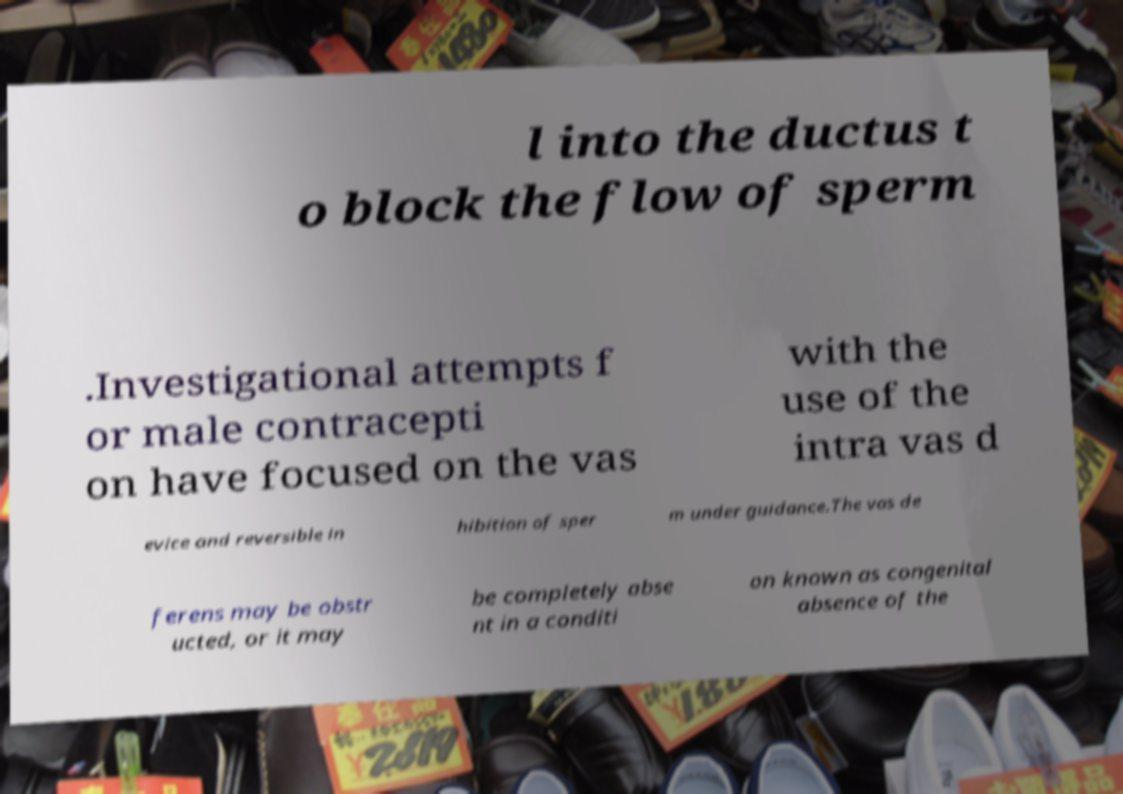Could you assist in decoding the text presented in this image and type it out clearly? l into the ductus t o block the flow of sperm .Investigational attempts f or male contracepti on have focused on the vas with the use of the intra vas d evice and reversible in hibition of sper m under guidance.The vas de ferens may be obstr ucted, or it may be completely abse nt in a conditi on known as congenital absence of the 